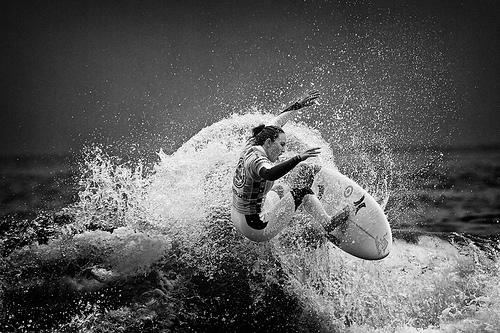Question: what color is the sky in this image?
Choices:
A. Grey.
B. Blue.
C. Orange.
D. Magenta.
Answer with the letter. Answer: A Question: what is the woman holding up in the air?
Choices:
A. Baby.
B. Apple.
C. Her hands.
D. Paper Towel.
Answer with the letter. Answer: C Question: why is the woman in the ocean?
Choices:
A. Swimming.
B. Relaxing.
C. Vacationing.
D. She is surfing.
Answer with the letter. Answer: D Question: where is the woman?
Choices:
A. In the ocean.
B. On the beach.
C. In the snack bar.
D. On the chair.
Answer with the letter. Answer: A Question: who is surfing?
Choices:
A. The woman.
B. The man.
C. The professional surfer.
D. The boy.
Answer with the letter. Answer: A 